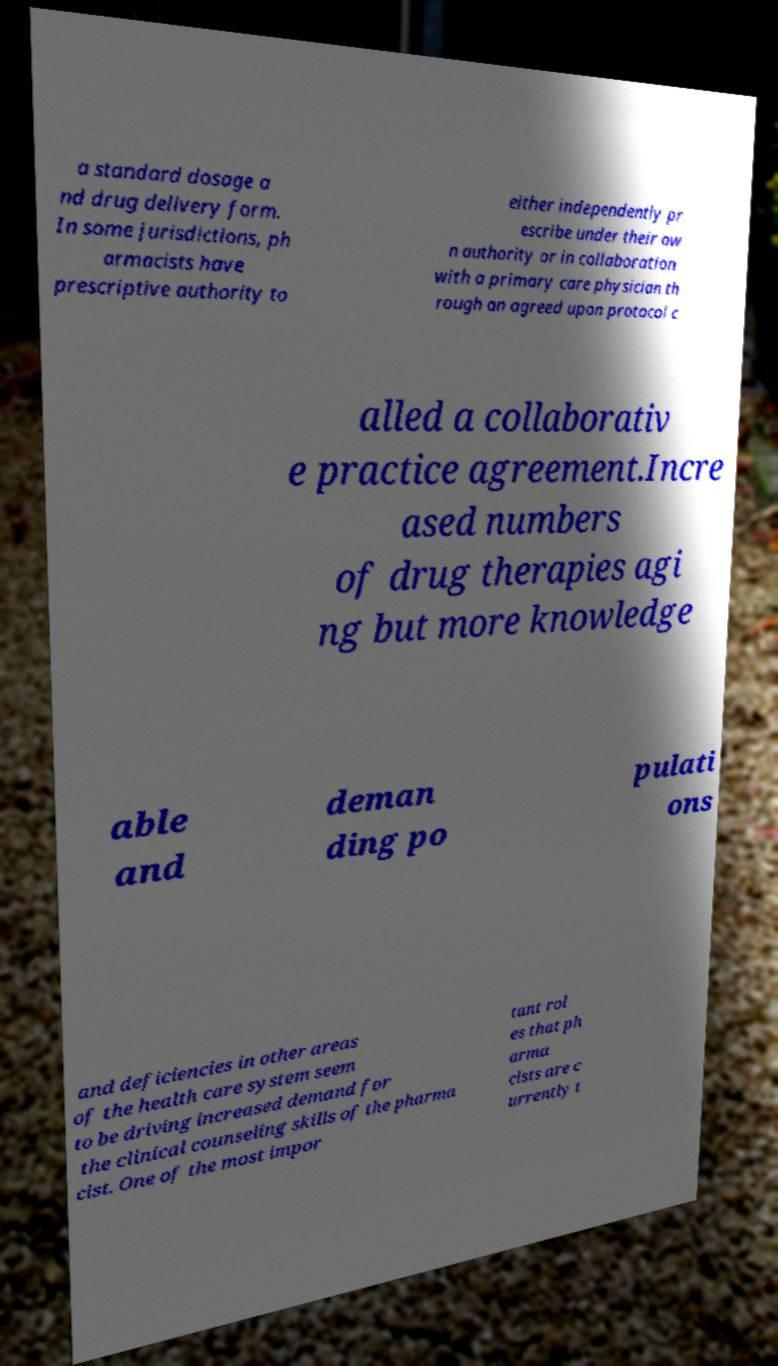Could you extract and type out the text from this image? a standard dosage a nd drug delivery form. In some jurisdictions, ph armacists have prescriptive authority to either independently pr escribe under their ow n authority or in collaboration with a primary care physician th rough an agreed upon protocol c alled a collaborativ e practice agreement.Incre ased numbers of drug therapies agi ng but more knowledge able and deman ding po pulati ons and deficiencies in other areas of the health care system seem to be driving increased demand for the clinical counseling skills of the pharma cist. One of the most impor tant rol es that ph arma cists are c urrently t 